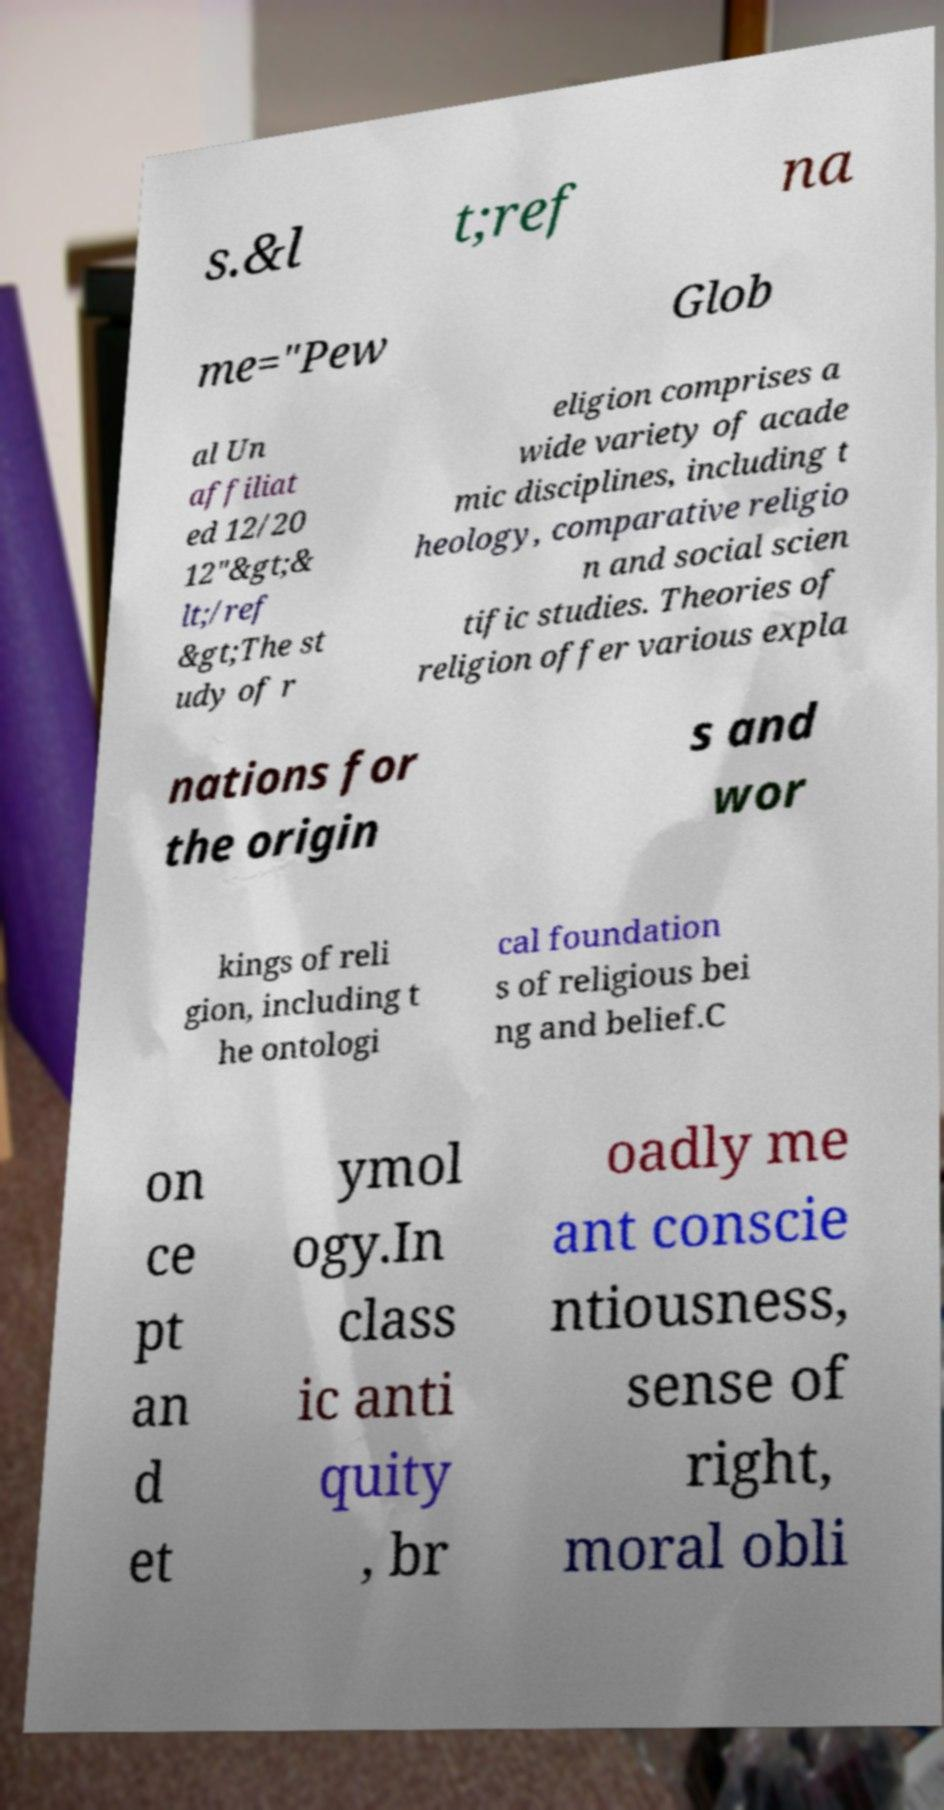There's text embedded in this image that I need extracted. Can you transcribe it verbatim? s.&l t;ref na me="Pew Glob al Un affiliat ed 12/20 12"&gt;& lt;/ref &gt;The st udy of r eligion comprises a wide variety of acade mic disciplines, including t heology, comparative religio n and social scien tific studies. Theories of religion offer various expla nations for the origin s and wor kings of reli gion, including t he ontologi cal foundation s of religious bei ng and belief.C on ce pt an d et ymol ogy.In class ic anti quity , br oadly me ant conscie ntiousness, sense of right, moral obli 